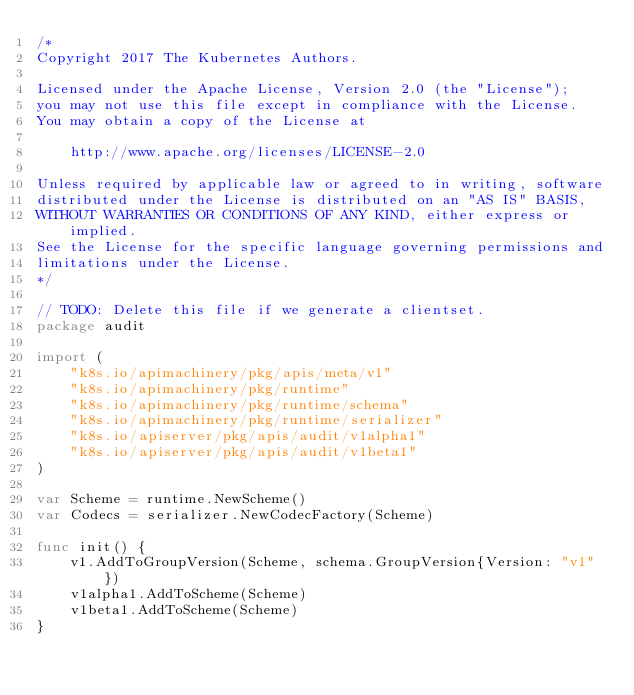Convert code to text. <code><loc_0><loc_0><loc_500><loc_500><_Go_>/*
Copyright 2017 The Kubernetes Authors.

Licensed under the Apache License, Version 2.0 (the "License");
you may not use this file except in compliance with the License.
You may obtain a copy of the License at

    http://www.apache.org/licenses/LICENSE-2.0

Unless required by applicable law or agreed to in writing, software
distributed under the License is distributed on an "AS IS" BASIS,
WITHOUT WARRANTIES OR CONDITIONS OF ANY KIND, either express or implied.
See the License for the specific language governing permissions and
limitations under the License.
*/

// TODO: Delete this file if we generate a clientset.
package audit

import (
	"k8s.io/apimachinery/pkg/apis/meta/v1"
	"k8s.io/apimachinery/pkg/runtime"
	"k8s.io/apimachinery/pkg/runtime/schema"
	"k8s.io/apimachinery/pkg/runtime/serializer"
	"k8s.io/apiserver/pkg/apis/audit/v1alpha1"
	"k8s.io/apiserver/pkg/apis/audit/v1beta1"
)

var Scheme = runtime.NewScheme()
var Codecs = serializer.NewCodecFactory(Scheme)

func init() {
	v1.AddToGroupVersion(Scheme, schema.GroupVersion{Version: "v1"})
	v1alpha1.AddToScheme(Scheme)
	v1beta1.AddToScheme(Scheme)
}
</code> 